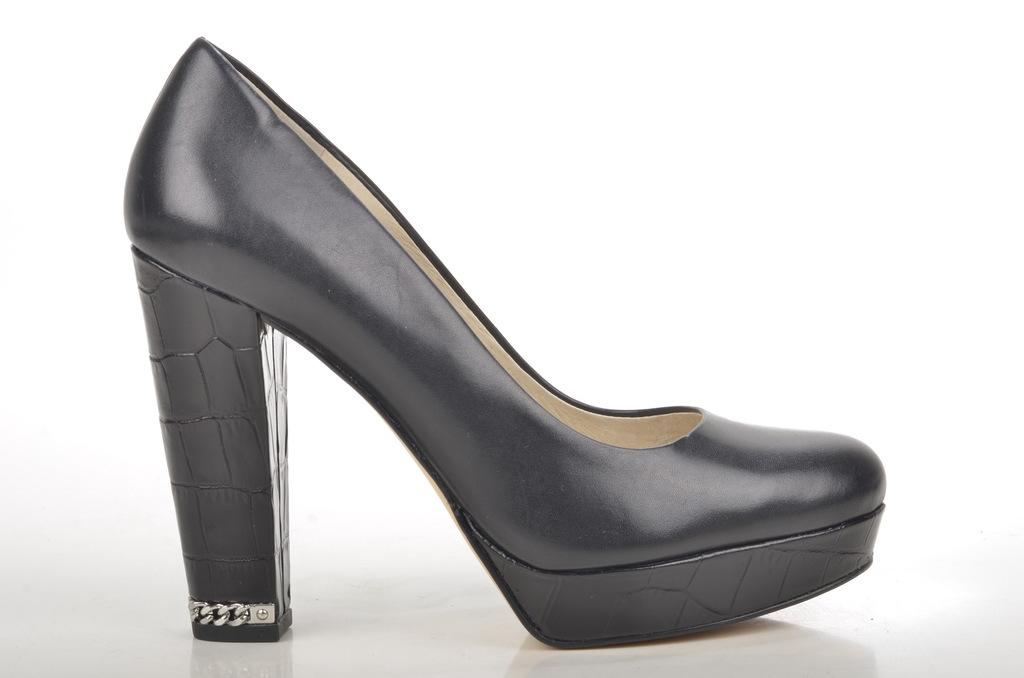What color is the shoe in the image? The shoe in the image is black. Can you describe the type of shoe in the image? The provided facts do not specify the type of shoe, only its color. Is there any other information about the shoe that can be determined from the image? No, the only information provided is that the shoe is black. How does the shoe make use of sleet in the image? There is no mention of sleet in the image, and no indication that the shoe is interacting with sleet in any way. 